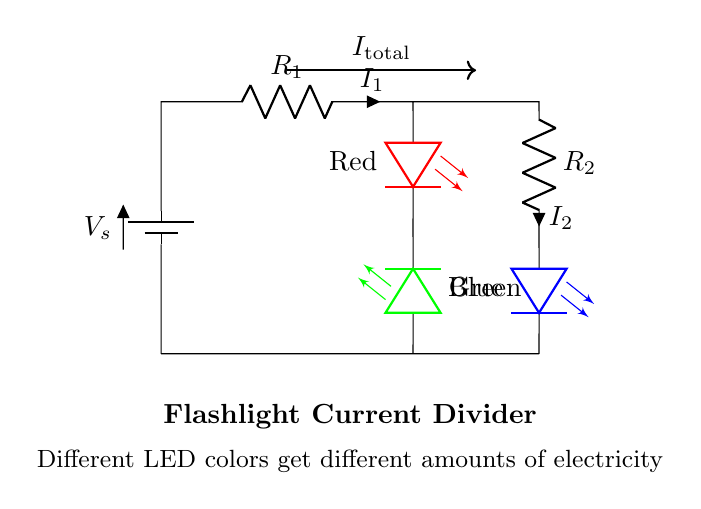What is the total current in the circuit? The total current, represented as \( I_\text{total} \), is indicated as an arrow pointing from the top of the circuit. It denotes the current flowing from the battery to the resistors and LEDs.
Answer: \( I_\text{total} \) How many LEDs are in this flashlight circuit? The circuit diagram shows a total of three LEDs: one red, one green, and one blue. This is counted by identifying each LED symbol in the diagram.
Answer: Three What color LED gets the most current? The current division depends on the resistance of each branch. If \( R_1 \) has a lower resistance than \( R_2 \), then the red LED would receive more current. Since we can't see the specific resistor values, this cannot be determined directly.
Answer: Not determinable Which LED is associated with \( I_1 \)? The red LED is connected directly after resistor \( R_1 \), and \( I_1 \) indicates the current through this part of the circuit. Since \( I_1 \) flows through the red LED, that is its association.
Answer: Red LED What does the circuit's symbol \( R_1 \) represent? In the circuit, \( R_1 \) is labeled as a resistor that influences the current flow through the circuit. Each resistor helps to manage how much current goes to its respective LED.
Answer: Resistor What is the color of the LED connected to \( R_2 \)? The circuit diagram shows that the blue LED is connected to \( R_2 \), as indicated by the label next to this LED. Thus, the answer is straightforward by identifying the components connected with \( R_2 \).
Answer: Blue LED 